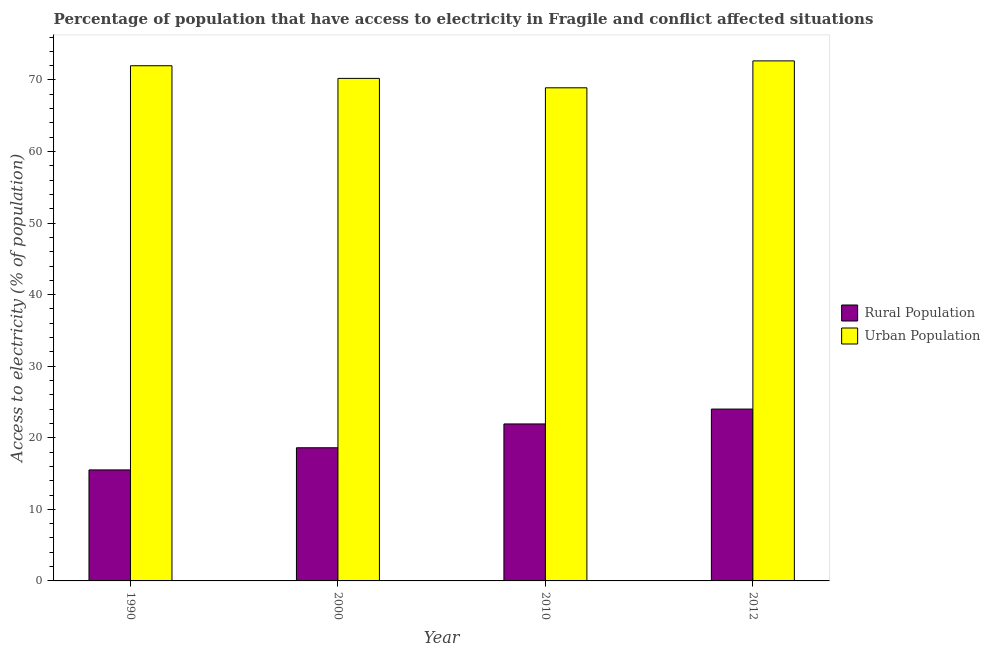Are the number of bars per tick equal to the number of legend labels?
Offer a very short reply. Yes. Are the number of bars on each tick of the X-axis equal?
Give a very brief answer. Yes. How many bars are there on the 1st tick from the left?
Offer a very short reply. 2. How many bars are there on the 4th tick from the right?
Offer a terse response. 2. What is the label of the 4th group of bars from the left?
Give a very brief answer. 2012. In how many cases, is the number of bars for a given year not equal to the number of legend labels?
Keep it short and to the point. 0. What is the percentage of rural population having access to electricity in 2010?
Provide a succinct answer. 21.94. Across all years, what is the maximum percentage of urban population having access to electricity?
Your response must be concise. 72.67. Across all years, what is the minimum percentage of urban population having access to electricity?
Keep it short and to the point. 68.91. In which year was the percentage of rural population having access to electricity maximum?
Make the answer very short. 2012. In which year was the percentage of urban population having access to electricity minimum?
Provide a succinct answer. 2010. What is the total percentage of urban population having access to electricity in the graph?
Ensure brevity in your answer.  283.79. What is the difference between the percentage of rural population having access to electricity in 1990 and that in 2000?
Offer a very short reply. -3.1. What is the difference between the percentage of rural population having access to electricity in 2012 and the percentage of urban population having access to electricity in 2010?
Ensure brevity in your answer.  2.08. What is the average percentage of rural population having access to electricity per year?
Keep it short and to the point. 20.02. In how many years, is the percentage of rural population having access to electricity greater than 26 %?
Provide a short and direct response. 0. What is the ratio of the percentage of rural population having access to electricity in 2000 to that in 2010?
Offer a very short reply. 0.85. What is the difference between the highest and the second highest percentage of rural population having access to electricity?
Ensure brevity in your answer.  2.08. What is the difference between the highest and the lowest percentage of urban population having access to electricity?
Your answer should be compact. 3.76. In how many years, is the percentage of rural population having access to electricity greater than the average percentage of rural population having access to electricity taken over all years?
Your answer should be very brief. 2. What does the 1st bar from the left in 2010 represents?
Your answer should be compact. Rural Population. What does the 1st bar from the right in 1990 represents?
Ensure brevity in your answer.  Urban Population. How many bars are there?
Offer a terse response. 8. How many years are there in the graph?
Offer a terse response. 4. What is the difference between two consecutive major ticks on the Y-axis?
Offer a terse response. 10. Are the values on the major ticks of Y-axis written in scientific E-notation?
Give a very brief answer. No. How are the legend labels stacked?
Provide a succinct answer. Vertical. What is the title of the graph?
Your response must be concise. Percentage of population that have access to electricity in Fragile and conflict affected situations. What is the label or title of the X-axis?
Give a very brief answer. Year. What is the label or title of the Y-axis?
Keep it short and to the point. Access to electricity (% of population). What is the Access to electricity (% of population) in Rural Population in 1990?
Provide a succinct answer. 15.51. What is the Access to electricity (% of population) in Urban Population in 1990?
Provide a succinct answer. 71.99. What is the Access to electricity (% of population) in Rural Population in 2000?
Offer a terse response. 18.61. What is the Access to electricity (% of population) of Urban Population in 2000?
Ensure brevity in your answer.  70.22. What is the Access to electricity (% of population) in Rural Population in 2010?
Your answer should be very brief. 21.94. What is the Access to electricity (% of population) of Urban Population in 2010?
Your answer should be compact. 68.91. What is the Access to electricity (% of population) in Rural Population in 2012?
Make the answer very short. 24.01. What is the Access to electricity (% of population) of Urban Population in 2012?
Ensure brevity in your answer.  72.67. Across all years, what is the maximum Access to electricity (% of population) of Rural Population?
Provide a succinct answer. 24.01. Across all years, what is the maximum Access to electricity (% of population) of Urban Population?
Provide a succinct answer. 72.67. Across all years, what is the minimum Access to electricity (% of population) of Rural Population?
Provide a succinct answer. 15.51. Across all years, what is the minimum Access to electricity (% of population) in Urban Population?
Your answer should be very brief. 68.91. What is the total Access to electricity (% of population) in Rural Population in the graph?
Offer a terse response. 80.07. What is the total Access to electricity (% of population) in Urban Population in the graph?
Provide a succinct answer. 283.79. What is the difference between the Access to electricity (% of population) of Rural Population in 1990 and that in 2000?
Give a very brief answer. -3.1. What is the difference between the Access to electricity (% of population) of Urban Population in 1990 and that in 2000?
Your answer should be compact. 1.77. What is the difference between the Access to electricity (% of population) of Rural Population in 1990 and that in 2010?
Offer a terse response. -6.42. What is the difference between the Access to electricity (% of population) in Urban Population in 1990 and that in 2010?
Offer a very short reply. 3.08. What is the difference between the Access to electricity (% of population) of Rural Population in 1990 and that in 2012?
Provide a succinct answer. -8.5. What is the difference between the Access to electricity (% of population) in Urban Population in 1990 and that in 2012?
Ensure brevity in your answer.  -0.68. What is the difference between the Access to electricity (% of population) of Rural Population in 2000 and that in 2010?
Your answer should be compact. -3.33. What is the difference between the Access to electricity (% of population) in Urban Population in 2000 and that in 2010?
Offer a very short reply. 1.32. What is the difference between the Access to electricity (% of population) in Rural Population in 2000 and that in 2012?
Offer a very short reply. -5.41. What is the difference between the Access to electricity (% of population) in Urban Population in 2000 and that in 2012?
Your response must be concise. -2.45. What is the difference between the Access to electricity (% of population) in Rural Population in 2010 and that in 2012?
Your answer should be very brief. -2.08. What is the difference between the Access to electricity (% of population) in Urban Population in 2010 and that in 2012?
Ensure brevity in your answer.  -3.76. What is the difference between the Access to electricity (% of population) in Rural Population in 1990 and the Access to electricity (% of population) in Urban Population in 2000?
Provide a succinct answer. -54.71. What is the difference between the Access to electricity (% of population) in Rural Population in 1990 and the Access to electricity (% of population) in Urban Population in 2010?
Keep it short and to the point. -53.39. What is the difference between the Access to electricity (% of population) of Rural Population in 1990 and the Access to electricity (% of population) of Urban Population in 2012?
Your response must be concise. -57.16. What is the difference between the Access to electricity (% of population) of Rural Population in 2000 and the Access to electricity (% of population) of Urban Population in 2010?
Keep it short and to the point. -50.3. What is the difference between the Access to electricity (% of population) of Rural Population in 2000 and the Access to electricity (% of population) of Urban Population in 2012?
Your answer should be compact. -54.06. What is the difference between the Access to electricity (% of population) in Rural Population in 2010 and the Access to electricity (% of population) in Urban Population in 2012?
Provide a short and direct response. -50.73. What is the average Access to electricity (% of population) of Rural Population per year?
Your response must be concise. 20.02. What is the average Access to electricity (% of population) in Urban Population per year?
Your answer should be compact. 70.95. In the year 1990, what is the difference between the Access to electricity (% of population) of Rural Population and Access to electricity (% of population) of Urban Population?
Provide a short and direct response. -56.48. In the year 2000, what is the difference between the Access to electricity (% of population) of Rural Population and Access to electricity (% of population) of Urban Population?
Ensure brevity in your answer.  -51.62. In the year 2010, what is the difference between the Access to electricity (% of population) in Rural Population and Access to electricity (% of population) in Urban Population?
Keep it short and to the point. -46.97. In the year 2012, what is the difference between the Access to electricity (% of population) in Rural Population and Access to electricity (% of population) in Urban Population?
Your answer should be compact. -48.65. What is the ratio of the Access to electricity (% of population) of Rural Population in 1990 to that in 2000?
Your answer should be very brief. 0.83. What is the ratio of the Access to electricity (% of population) in Urban Population in 1990 to that in 2000?
Provide a succinct answer. 1.03. What is the ratio of the Access to electricity (% of population) in Rural Population in 1990 to that in 2010?
Offer a very short reply. 0.71. What is the ratio of the Access to electricity (% of population) in Urban Population in 1990 to that in 2010?
Offer a very short reply. 1.04. What is the ratio of the Access to electricity (% of population) of Rural Population in 1990 to that in 2012?
Provide a short and direct response. 0.65. What is the ratio of the Access to electricity (% of population) in Urban Population in 1990 to that in 2012?
Your answer should be compact. 0.99. What is the ratio of the Access to electricity (% of population) in Rural Population in 2000 to that in 2010?
Give a very brief answer. 0.85. What is the ratio of the Access to electricity (% of population) in Urban Population in 2000 to that in 2010?
Your answer should be very brief. 1.02. What is the ratio of the Access to electricity (% of population) of Rural Population in 2000 to that in 2012?
Provide a succinct answer. 0.77. What is the ratio of the Access to electricity (% of population) of Urban Population in 2000 to that in 2012?
Your answer should be compact. 0.97. What is the ratio of the Access to electricity (% of population) of Rural Population in 2010 to that in 2012?
Offer a very short reply. 0.91. What is the ratio of the Access to electricity (% of population) in Urban Population in 2010 to that in 2012?
Your answer should be very brief. 0.95. What is the difference between the highest and the second highest Access to electricity (% of population) in Rural Population?
Make the answer very short. 2.08. What is the difference between the highest and the second highest Access to electricity (% of population) in Urban Population?
Keep it short and to the point. 0.68. What is the difference between the highest and the lowest Access to electricity (% of population) of Rural Population?
Provide a short and direct response. 8.5. What is the difference between the highest and the lowest Access to electricity (% of population) of Urban Population?
Make the answer very short. 3.76. 